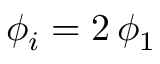Convert formula to latex. <formula><loc_0><loc_0><loc_500><loc_500>\phi _ { i } = 2 \, \phi _ { 1 }</formula> 